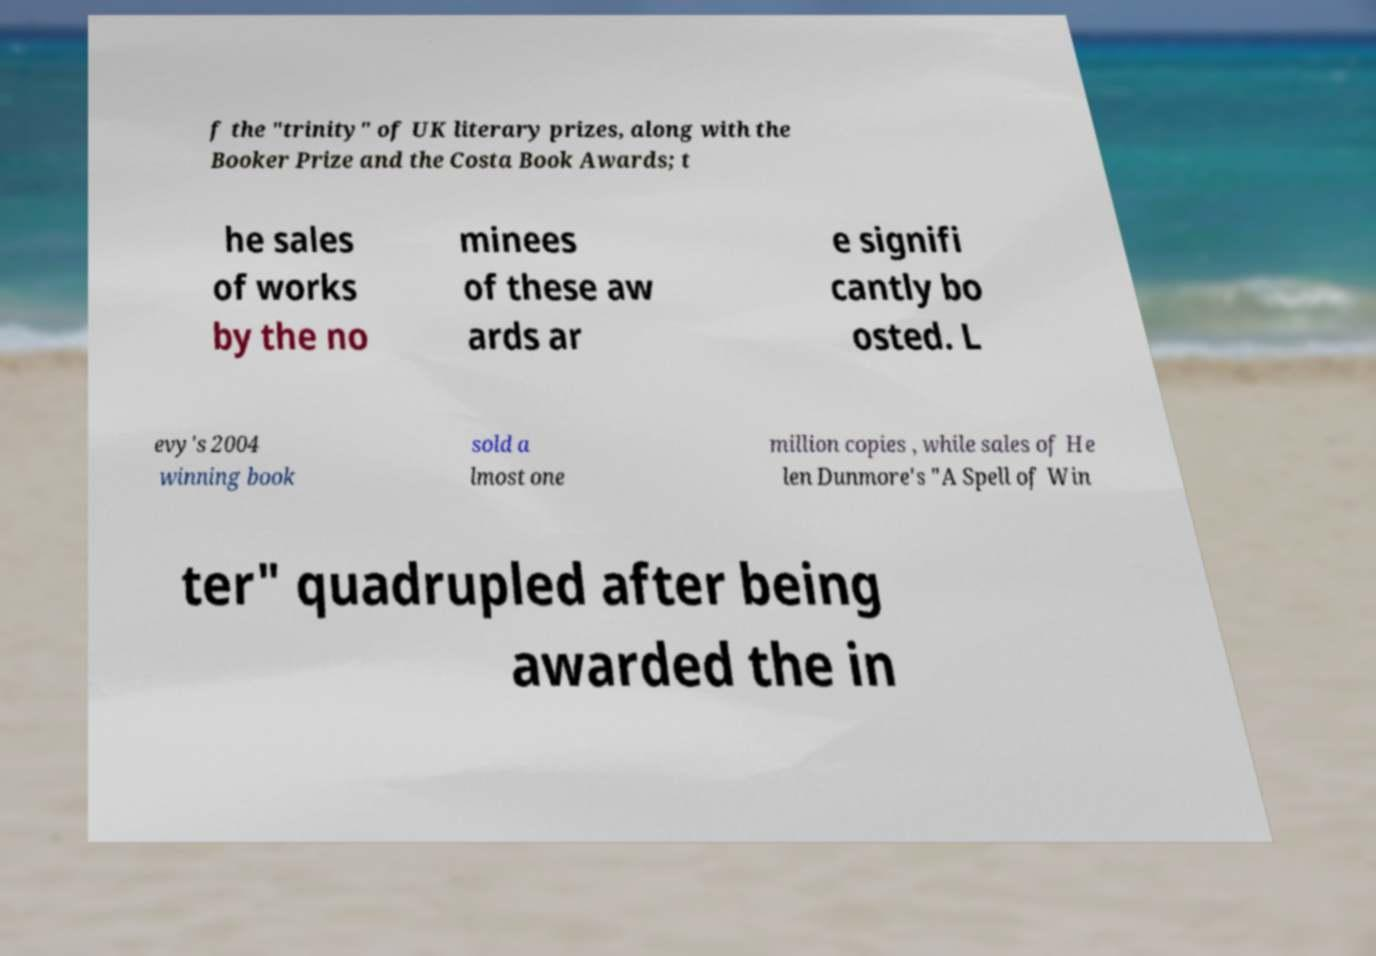I need the written content from this picture converted into text. Can you do that? f the "trinity" of UK literary prizes, along with the Booker Prize and the Costa Book Awards; t he sales of works by the no minees of these aw ards ar e signifi cantly bo osted. L evy's 2004 winning book sold a lmost one million copies , while sales of He len Dunmore's "A Spell of Win ter" quadrupled after being awarded the in 